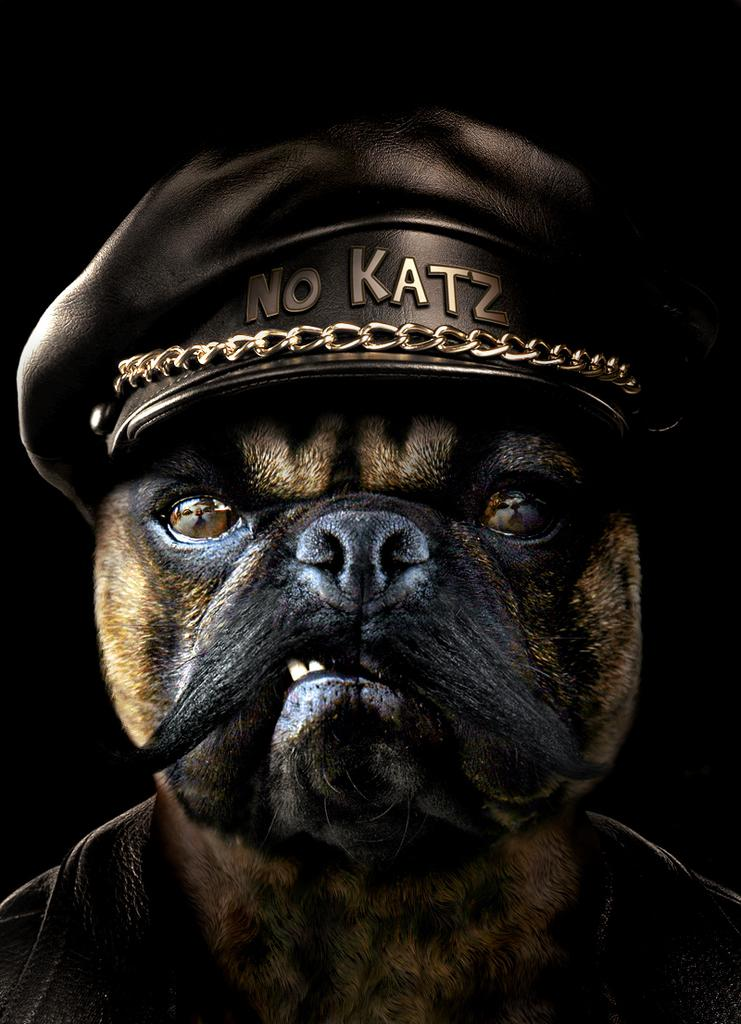What is the main subject of the image? There is a depiction of an animal in the image. What is the current status of the edge in the image? There is no mention of an edge in the image, as the only fact provided is about the depiction of an animal. 